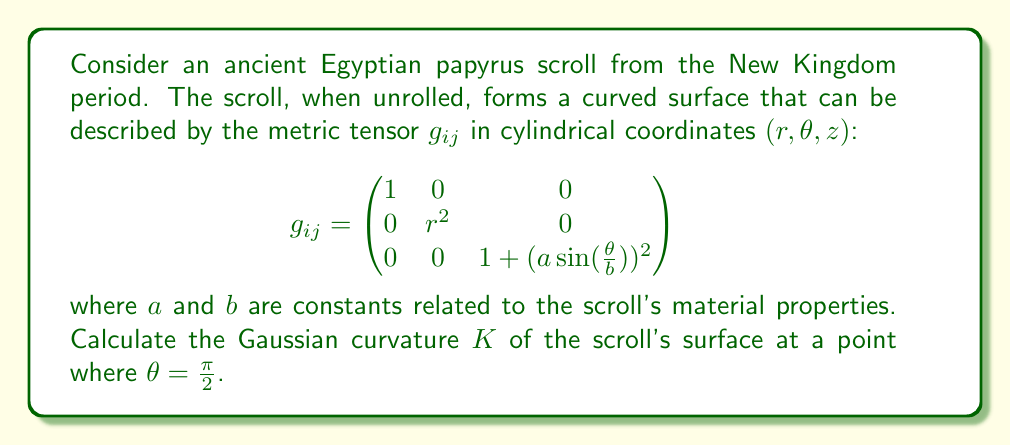Give your solution to this math problem. To solve this problem, we'll follow these steps:

1) The Gaussian curvature $K$ is given by:

   $$K = \frac{R_{1212}}{g}$$

   where $R_{1212}$ is a component of the Riemann curvature tensor and $g$ is the determinant of the metric tensor.

2) First, let's calculate $g$:

   $$g = \det(g_{ij}) = 1 \cdot r^2 \cdot (1 + (a\sin(\frac{\theta}{b}))^2) = r^2(1 + (a\sin(\frac{\theta}{b}))^2)$$

3) Now, we need to calculate $R_{1212}$. For this, we need to calculate the Christoffel symbols and then use them to calculate the Riemann tensor.

4) The non-zero Christoffel symbols are:

   $$\Gamma^1_{22} = -r$$
   $$\Gamma^2_{12} = \Gamma^2_{21} = \frac{1}{r}$$
   $$\Gamma^3_{23} = \Gamma^3_{32} = \frac{a^2\sin(\frac{\theta}{b})\cos(\frac{\theta}{b})}{b(1+(a\sin(\frac{\theta}{b}))^2)}$$

5) Using these, we can calculate $R_{1212}$:

   $$R_{1212} = \partial_1\Gamma^1_{22} - \partial_2\Gamma^1_{21} + \Gamma^1_{1k}\Gamma^k_{22} - \Gamma^1_{2k}\Gamma^k_{21} = -r$$

6) Now we can calculate $K$:

   $$K = \frac{R_{1212}}{g} = \frac{-r}{r^2(1 + (a\sin(\frac{\theta}{b}))^2)} = -\frac{1}{r(1 + (a\sin(\frac{\theta}{b}))^2)}$$

7) At $\theta = \frac{\pi}{2}$, this becomes:

   $$K = -\frac{1}{r(1 + a^2)}$$

This is our final answer for the Gaussian curvature at $\theta = \frac{\pi}{2}$.
Answer: $-\frac{1}{r(1 + a^2)}$ 